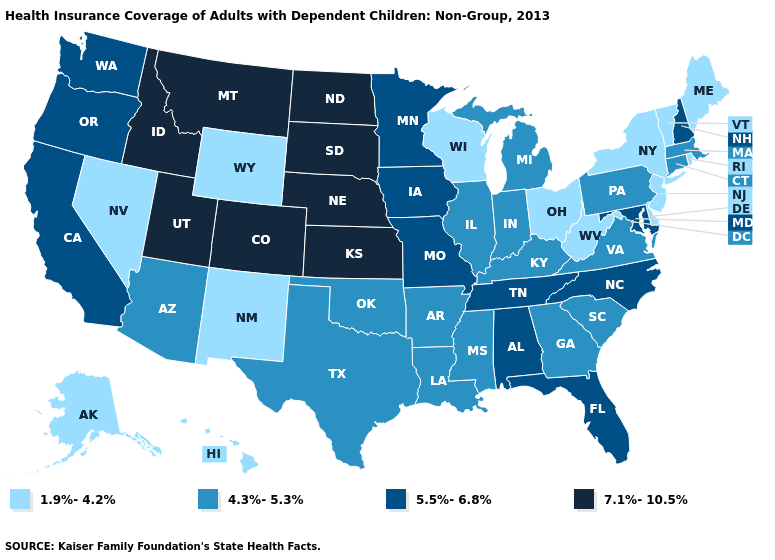Name the states that have a value in the range 1.9%-4.2%?
Write a very short answer. Alaska, Delaware, Hawaii, Maine, Nevada, New Jersey, New Mexico, New York, Ohio, Rhode Island, Vermont, West Virginia, Wisconsin, Wyoming. Name the states that have a value in the range 7.1%-10.5%?
Short answer required. Colorado, Idaho, Kansas, Montana, Nebraska, North Dakota, South Dakota, Utah. Name the states that have a value in the range 5.5%-6.8%?
Be succinct. Alabama, California, Florida, Iowa, Maryland, Minnesota, Missouri, New Hampshire, North Carolina, Oregon, Tennessee, Washington. Among the states that border South Dakota , does Nebraska have the highest value?
Concise answer only. Yes. Which states have the lowest value in the USA?
Concise answer only. Alaska, Delaware, Hawaii, Maine, Nevada, New Jersey, New Mexico, New York, Ohio, Rhode Island, Vermont, West Virginia, Wisconsin, Wyoming. What is the value of Hawaii?
Short answer required. 1.9%-4.2%. What is the value of North Carolina?
Be succinct. 5.5%-6.8%. Name the states that have a value in the range 7.1%-10.5%?
Answer briefly. Colorado, Idaho, Kansas, Montana, Nebraska, North Dakota, South Dakota, Utah. What is the highest value in the Northeast ?
Quick response, please. 5.5%-6.8%. Name the states that have a value in the range 1.9%-4.2%?
Short answer required. Alaska, Delaware, Hawaii, Maine, Nevada, New Jersey, New Mexico, New York, Ohio, Rhode Island, Vermont, West Virginia, Wisconsin, Wyoming. Does the first symbol in the legend represent the smallest category?
Write a very short answer. Yes. Does Massachusetts have the same value as Minnesota?
Be succinct. No. Does West Virginia have the lowest value in the USA?
Give a very brief answer. Yes. Name the states that have a value in the range 1.9%-4.2%?
Be succinct. Alaska, Delaware, Hawaii, Maine, Nevada, New Jersey, New Mexico, New York, Ohio, Rhode Island, Vermont, West Virginia, Wisconsin, Wyoming. What is the value of Louisiana?
Concise answer only. 4.3%-5.3%. 